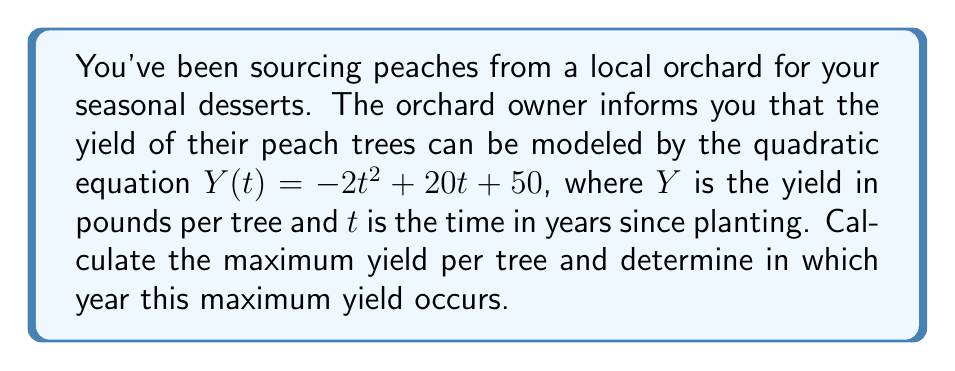Solve this math problem. To solve this problem, we need to follow these steps:

1) The quadratic equation given is $Y(t) = -2t^2 + 20t + 50$

2) For a quadratic equation in the form $f(x) = ax^2 + bx + c$, the vertex formula gives us the maximum or minimum point:

   $t = -\frac{b}{2a}$

3) In our case, $a = -2$, $b = 20$, and $c = 50$. Let's substitute these values:

   $t = -\frac{20}{2(-2)} = -\frac{20}{-4} = 5$

4) This means the maximum yield occurs 5 years after planting.

5) To find the maximum yield, we substitute $t = 5$ into our original equation:

   $Y(5) = -2(5)^2 + 20(5) + 50$
   $= -2(25) + 100 + 50$
   $= -50 + 100 + 50$
   $= 100$

Therefore, the maximum yield is 100 pounds per tree, occurring 5 years after planting.
Answer: Maximum yield: 100 pounds per tree
Year of maximum yield: 5 years after planting 